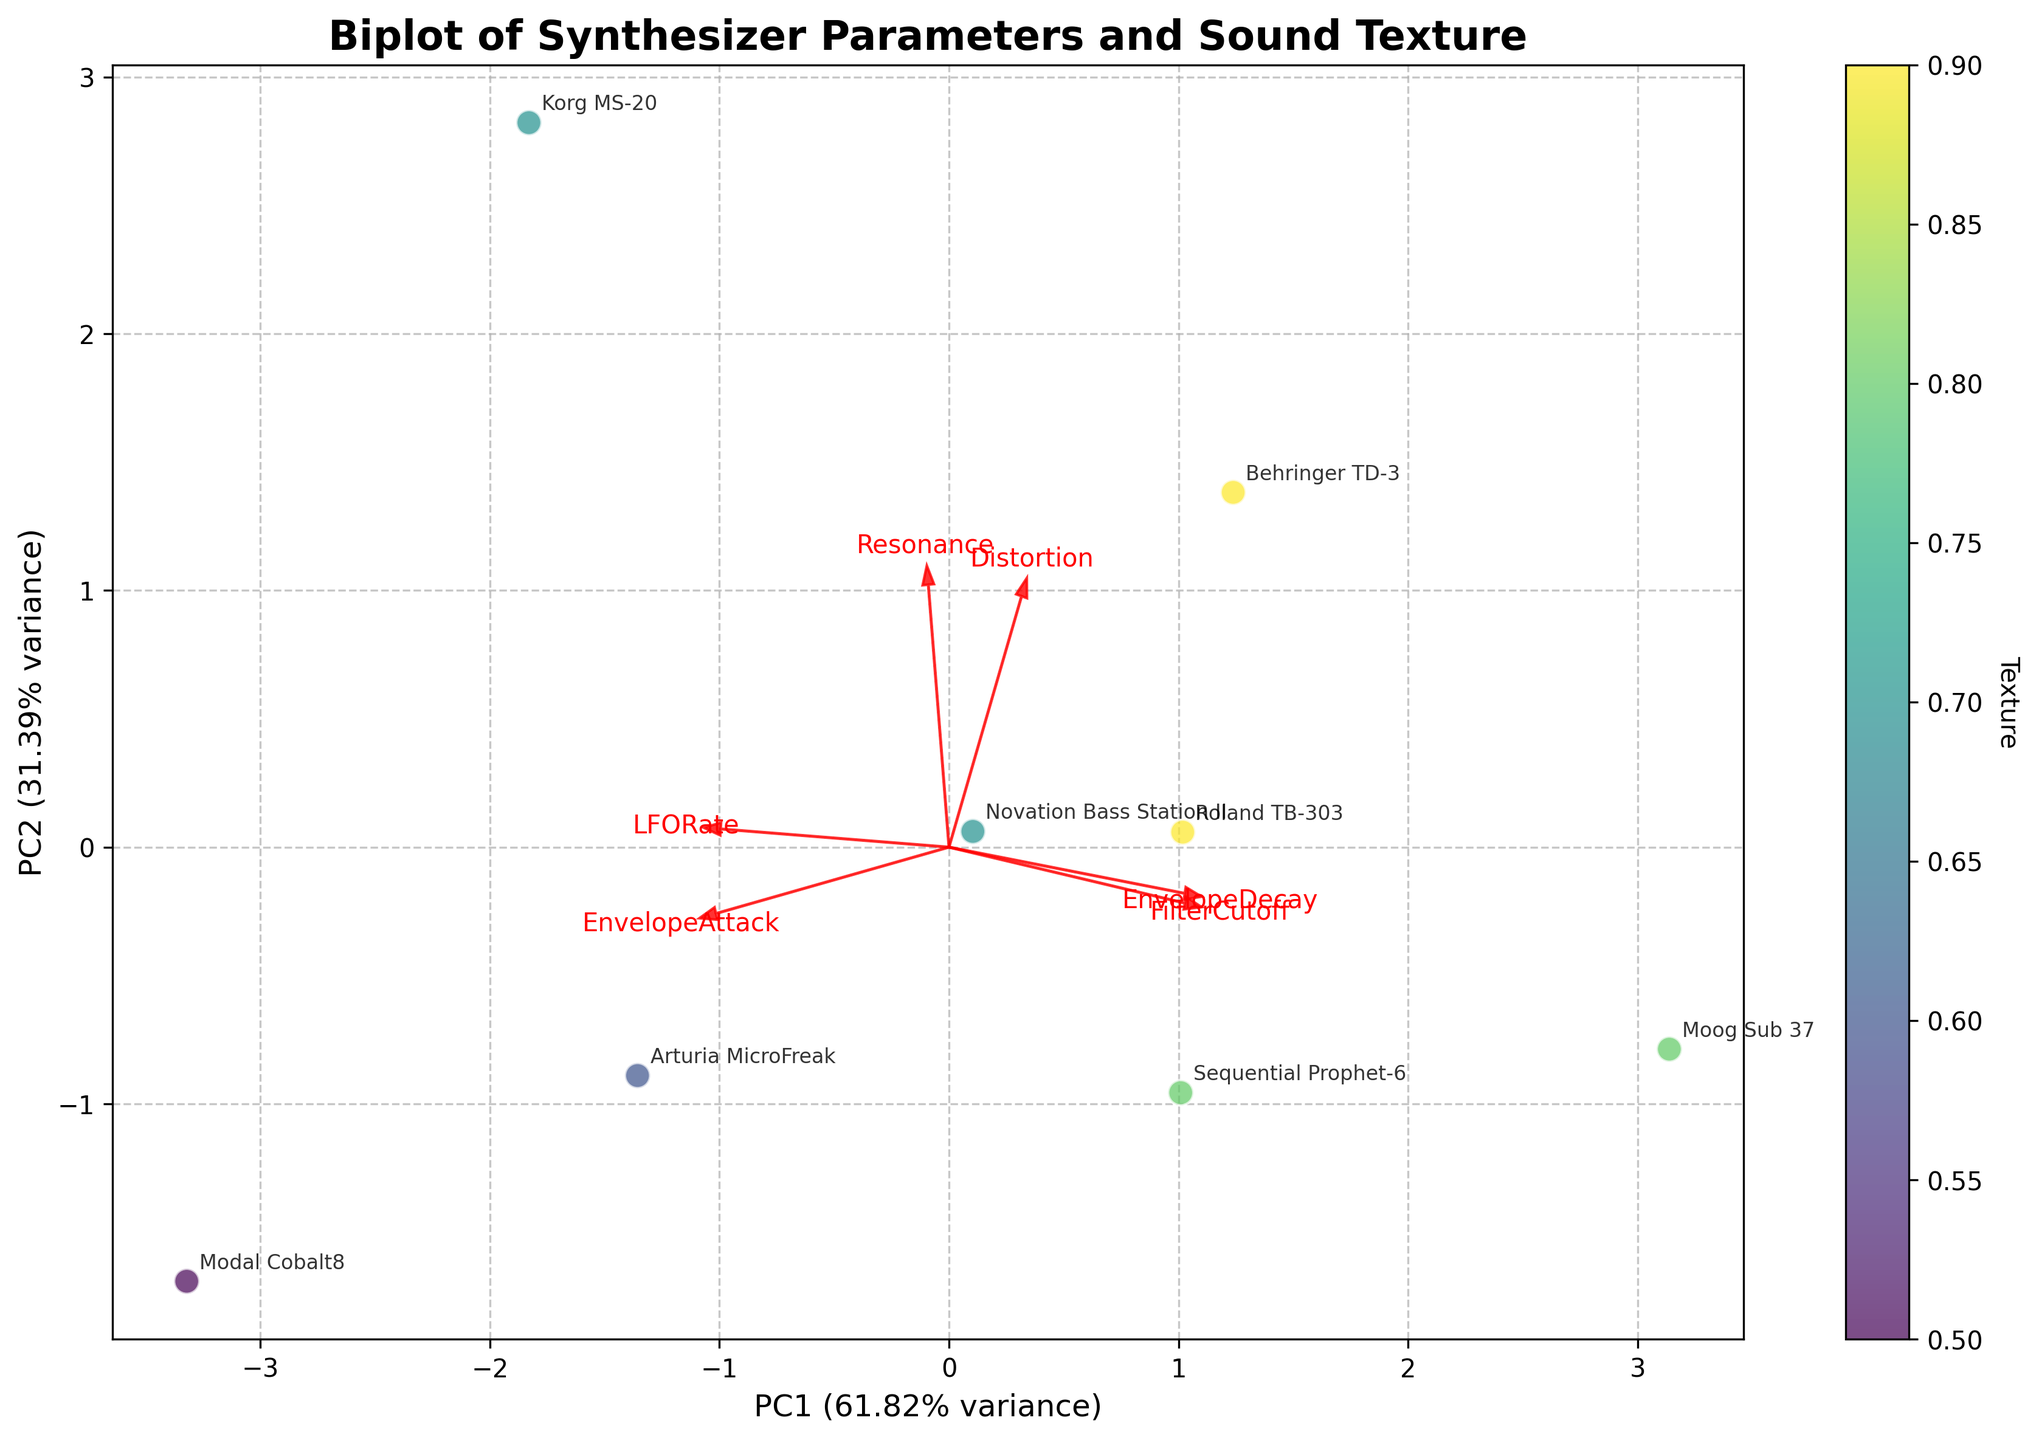what is the title of the plot? The title appears at the top of the plot, specifying the context and main focus of the visualization. It reads "Biplot of Synthesizer Parameters and Sound Texture"
Answer: Biplot of Synthesizer Parameters and Sound Texture How many synthesizers are represented in the plot? Each synthesizer is annotated in the plot with its label. Counting these annotations gives the total number, which is 8.
Answer: 8 What is the color scale used in the plot, and what does it represent? The color scale runs from light to dark colors. It is associated with the 'Texture' of the synthesizers, as indicated by the colorbar on the side showing varying shades corresponding to Texture values.
Answer: Texture Which synthesizer is positioned closest to the highest PC1 value? The positions of synthesizers are determined by their PC1 and PC2 coordinates. By examining the plot, we see that the "Moog Sub 37" is positioned closest to the rightmost side of the x-axis, which represents the highest PC1 value.
Answer: Moog Sub 37 Is there any synthesizer with a very high Texture value but low PC2 value? Linked to both PC2 positions and Texture colorings, the "Behringer TD-3" has a high Texture (darker color) and lower PC2 value (within the range from lower PC1).
Answer: Behringer TD-3 Which synthesizer has the highest resonance value and where is it located in the plot? By checking the plot annotations for synthesizers and loading vectors, "Korg MS-20" has the highest resonance as its position aligns closely with the direction of the Resonance vector.
Answer: Korg MS-20 What percentage of the total variance is explained by PC1? This information is printed next to the x-axis label, showing that PC1 accounts for around 43.47% of the variance.
Answer: 43.47% Which parameter has the largest loading on PC1? Loadings are displayed with arrows representing their direction and magnitude. The FilterCutoff parameter's arrow extends the farthest along the PC1 axis indicating the strongest loading.
Answer: FilterCutoff 